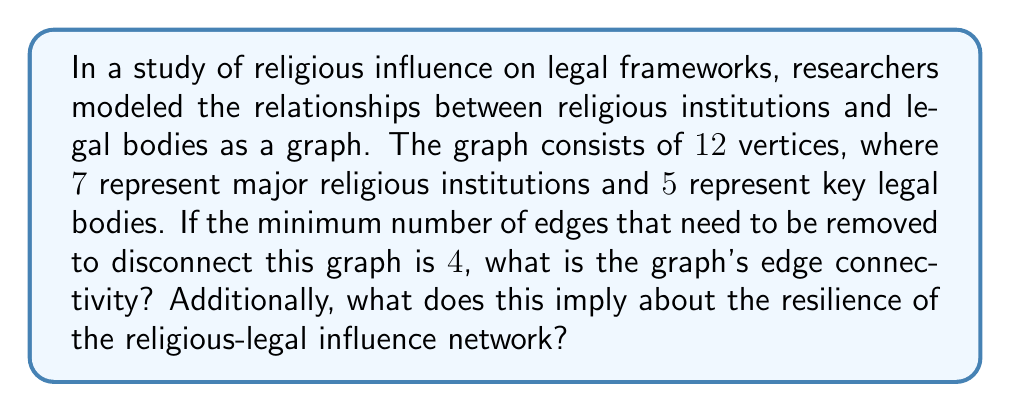Can you solve this math problem? To solve this problem, we need to understand the concept of edge connectivity in graph theory and its implications for network resilience.

1. Edge Connectivity Definition:
   The edge connectivity of a graph, denoted as $\lambda(G)$, is the minimum number of edges that need to be removed to disconnect the graph.

2. Given Information:
   - The graph has 12 vertices (7 religious institutions + 5 legal bodies)
   - The minimum number of edges to be removed to disconnect the graph is 4

3. Determining Edge Connectivity:
   The edge connectivity is directly equal to the minimum number of edges that need to be removed to disconnect the graph. Therefore:

   $$\lambda(G) = 4$$

4. Implications for Network Resilience:
   The edge connectivity provides insight into the resilience of the network:
   
   a) A higher edge connectivity indicates a more robust network, as more edges need to be removed to disconnect it.
   
   b) In this case, $\lambda(G) = 4$ suggests a moderate level of resilience. At least 4 distinct influence pathways must be severed to disconnect the religious-legal network.
   
   c) The interpretation in the context of religious influence on legal frameworks:
      - There are multiple pathways of influence between religious institutions and legal bodies.
      - The network can withstand the removal of up to 3 connections without becoming disconnected.
      - This implies a certain degree of robustness in the relationship between religious and legal entities.

5. Menger's Theorem Connection:
   Menger's theorem states that the edge connectivity of a graph is equal to the minimum number of edge-disjoint paths between any two vertices. This means there are at least 4 edge-disjoint paths between any religious institution and any legal body in the network.
Answer: The edge connectivity of the graph is 4. This implies that the religious-legal influence network has a moderate level of resilience, requiring the removal of at least 4 distinct influence pathways to disconnect religious institutions from legal bodies. 